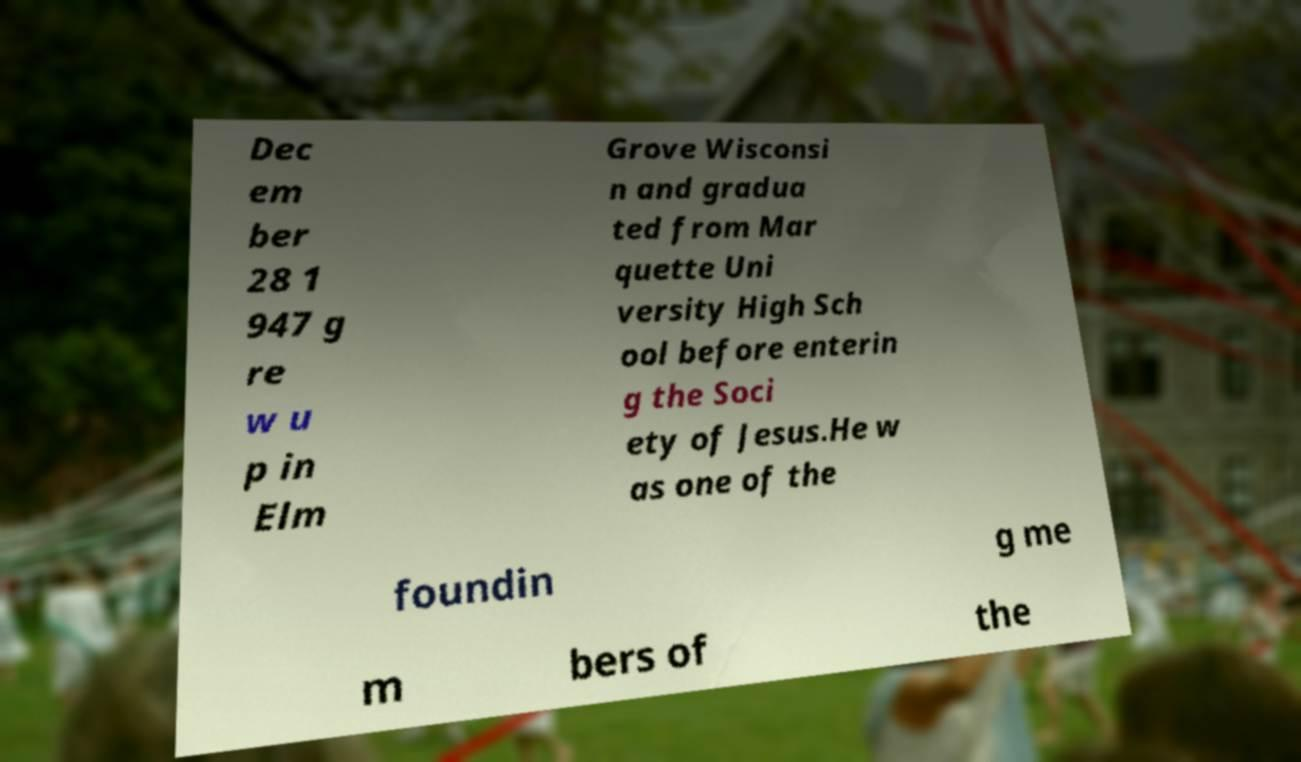I need the written content from this picture converted into text. Can you do that? Dec em ber 28 1 947 g re w u p in Elm Grove Wisconsi n and gradua ted from Mar quette Uni versity High Sch ool before enterin g the Soci ety of Jesus.He w as one of the foundin g me m bers of the 